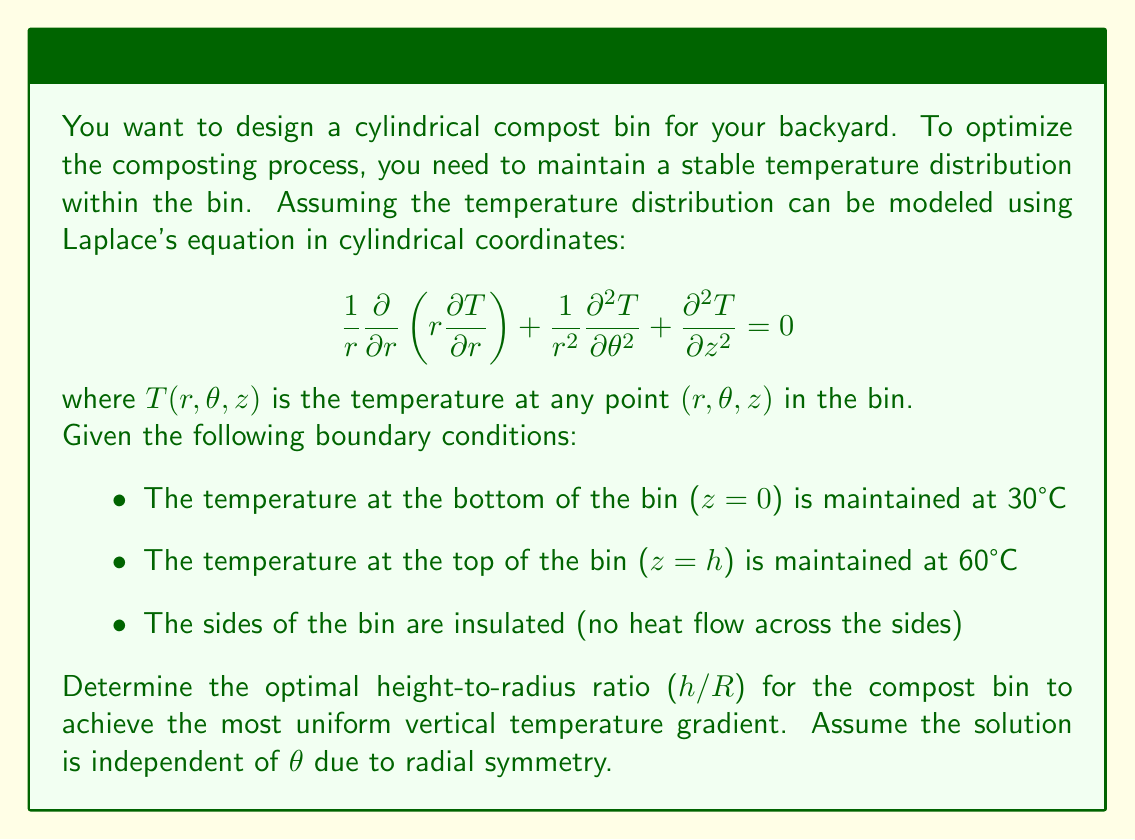Could you help me with this problem? To solve this problem, we'll follow these steps:

1) Simplify Laplace's equation due to radial symmetry:
   Since the temperature is independent of $\theta$, the equation reduces to:
   
   $$\frac{1}{r}\frac{\partial}{\partial r}\left(r\frac{\partial T}{\partial r}\right) + \frac{\partial^2 T}{\partial z^2} = 0$$

2) Apply separation of variables:
   Let $T(r,z) = R(r)Z(z)$. Substituting this into the simplified equation:
   
   $$\frac{1}{rR}\frac{d}{dr}\left(r\frac{dR}{dr}\right) + \frac{1}{Z}\frac{d^2Z}{dz^2} = 0$$

3) Separate the variables:
   
   $$\frac{1}{rR}\frac{d}{dr}\left(r\frac{dR}{dr}\right) = -\frac{1}{Z}\frac{d^2Z}{dz^2} = -k^2$$
   
   Where $k$ is a separation constant.

4) Solve for Z(z):
   
   $$\frac{d^2Z}{dz^2} + k^2Z = 0$$
   
   The general solution is $Z(z) = A\cos(kz) + B\sin(kz)$

5) Apply boundary conditions:
   At $z = 0$, $T = 30°C$, so $Z(0) = 30$
   At $z = h$, $T = 60°C$, so $Z(h) = 60$
   
   This gives us:
   $30 = A$
   $60 = A\cos(kh) + B\sin(kh)$

6) The most uniform vertical gradient occurs when $k = \frac{\pi}{2h}$, which makes $Z(z)$ a quarter sine wave.

7) With this $k$, we have:
   $60 = 30\cos(\frac{\pi}{2}) + B\sin(\frac{\pi}{2})$
   $60 = B$

8) So our temperature distribution is:
   
   $$T(r,z) = 30 + 30\sin(\frac{\pi z}{2h})$$

9) For the radial component, we need to solve:
   
   $$\frac{1}{r}\frac{d}{dr}\left(r\frac{dR}{dr}\right) + (\frac{\pi}{2h})^2R = 0$$

   This is a Bessel equation of order 0. The solution that remains finite at $r = 0$ is:
   
   $$R(r) = C J_0(\frac{\pi r}{2h})$$

   where $J_0$ is the Bessel function of the first kind of order 0.

10) To satisfy the insulated sides condition, we need:
    
    $$\frac{dR}{dr}|_{r=R} = 0$$
    
    This occurs when $\frac{\pi R}{2h} = 2.4048$ (the first zero of $J_1$, the derivative of $J_0$)

11) Therefore, the optimal height-to-radius ratio is:
    
    $$\frac{h}{R} = \frac{\pi}{2(2.4048)} \approx 0.6533$$

This ratio ensures the most uniform vertical temperature gradient while satisfying the boundary conditions.
Answer: The optimal height-to-radius ratio (h/R) for the compost bin is approximately 0.6533. 